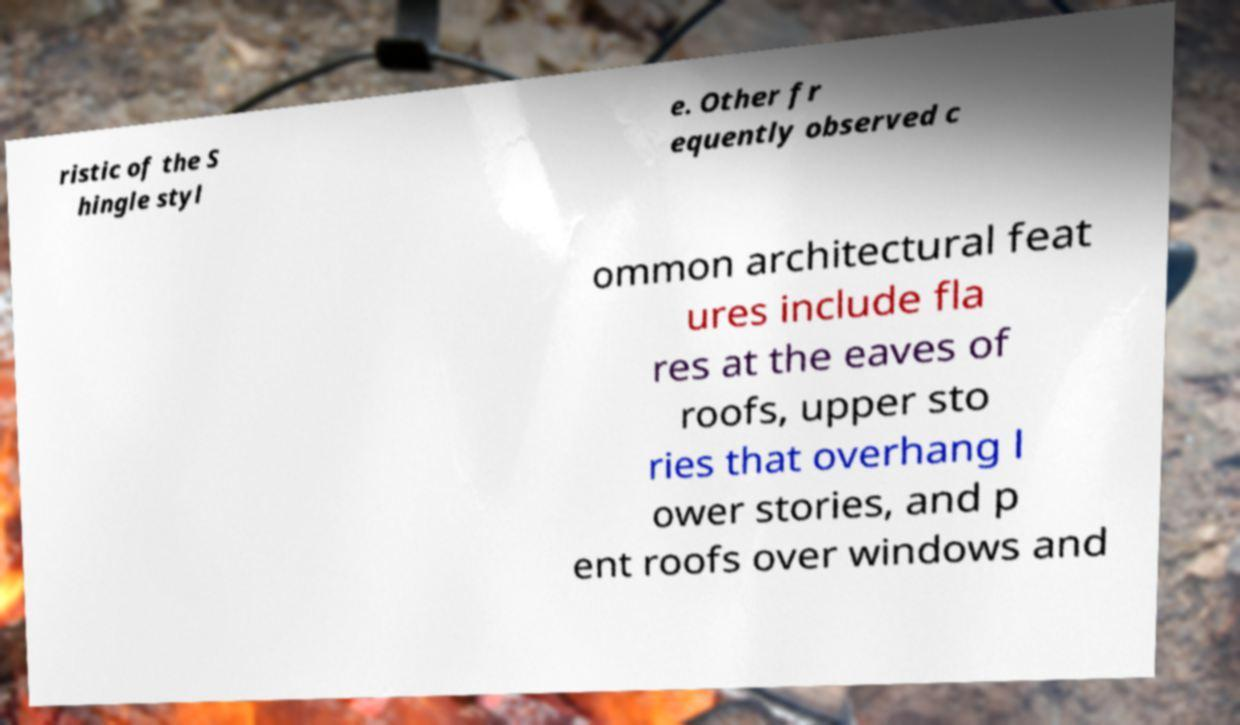Can you read and provide the text displayed in the image?This photo seems to have some interesting text. Can you extract and type it out for me? ristic of the S hingle styl e. Other fr equently observed c ommon architectural feat ures include fla res at the eaves of roofs, upper sto ries that overhang l ower stories, and p ent roofs over windows and 